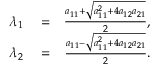<formula> <loc_0><loc_0><loc_500><loc_500>\begin{array} { r l r } { \lambda _ { 1 } } & = } & { \frac { a _ { 1 1 } + \sqrt { a _ { 1 1 } ^ { 2 } + 4 a _ { 1 2 } a _ { 2 1 } } } { 2 } , } \\ { \lambda _ { 2 } } & = } & { \frac { a _ { 1 1 } - \sqrt { a _ { 1 1 } ^ { 2 } + 4 a _ { 1 2 } a _ { 2 1 } } } { 2 } . } \end{array}</formula> 